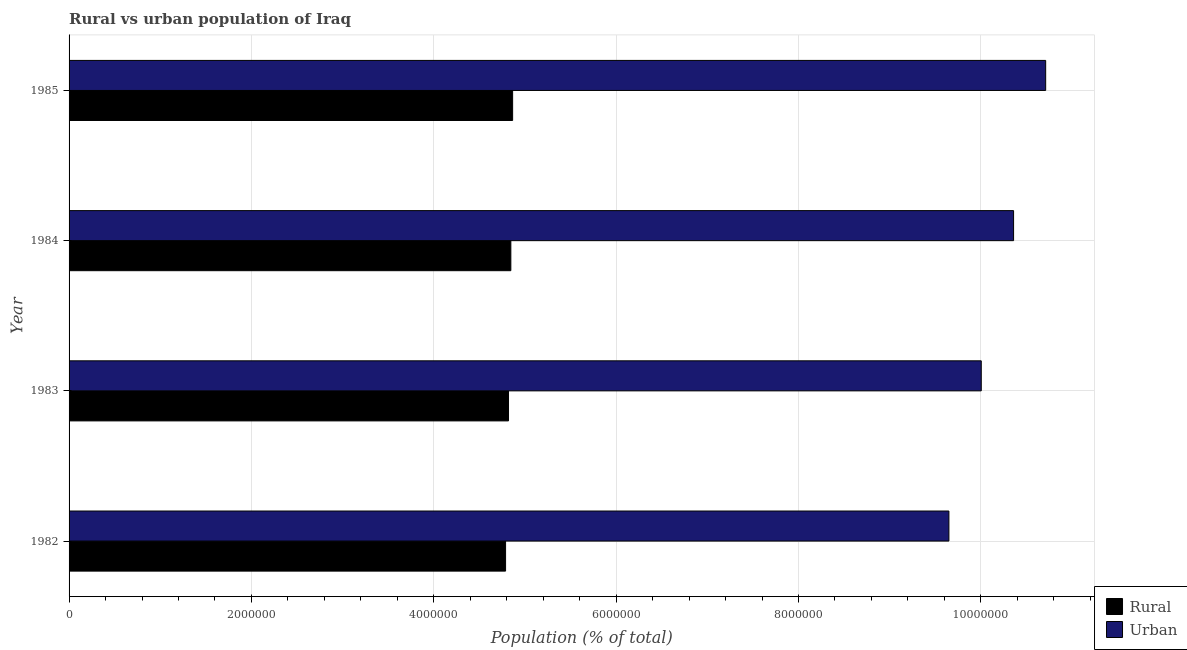How many different coloured bars are there?
Provide a succinct answer. 2. How many groups of bars are there?
Make the answer very short. 4. How many bars are there on the 1st tick from the top?
Make the answer very short. 2. What is the label of the 3rd group of bars from the top?
Provide a short and direct response. 1983. What is the rural population density in 1984?
Keep it short and to the point. 4.85e+06. Across all years, what is the maximum urban population density?
Provide a short and direct response. 1.07e+07. Across all years, what is the minimum urban population density?
Your answer should be very brief. 9.65e+06. In which year was the rural population density maximum?
Offer a very short reply. 1985. What is the total rural population density in the graph?
Your answer should be very brief. 1.93e+07. What is the difference between the rural population density in 1982 and that in 1984?
Make the answer very short. -5.78e+04. What is the difference between the urban population density in 1985 and the rural population density in 1984?
Provide a short and direct response. 5.87e+06. What is the average urban population density per year?
Provide a short and direct response. 1.02e+07. In the year 1982, what is the difference between the rural population density and urban population density?
Your answer should be compact. -4.86e+06. In how many years, is the rural population density greater than 10400000 %?
Provide a succinct answer. 0. Is the urban population density in 1983 less than that in 1985?
Offer a very short reply. Yes. Is the difference between the rural population density in 1983 and 1984 greater than the difference between the urban population density in 1983 and 1984?
Give a very brief answer. Yes. What is the difference between the highest and the second highest urban population density?
Your answer should be compact. 3.52e+05. What is the difference between the highest and the lowest rural population density?
Provide a succinct answer. 7.73e+04. In how many years, is the rural population density greater than the average rural population density taken over all years?
Your answer should be very brief. 2. Is the sum of the urban population density in 1983 and 1984 greater than the maximum rural population density across all years?
Keep it short and to the point. Yes. What does the 2nd bar from the top in 1984 represents?
Ensure brevity in your answer.  Rural. What does the 1st bar from the bottom in 1984 represents?
Provide a short and direct response. Rural. Does the graph contain grids?
Provide a short and direct response. Yes. Where does the legend appear in the graph?
Ensure brevity in your answer.  Bottom right. How are the legend labels stacked?
Make the answer very short. Vertical. What is the title of the graph?
Offer a very short reply. Rural vs urban population of Iraq. What is the label or title of the X-axis?
Provide a short and direct response. Population (% of total). What is the label or title of the Y-axis?
Provide a short and direct response. Year. What is the Population (% of total) of Rural in 1982?
Keep it short and to the point. 4.79e+06. What is the Population (% of total) in Urban in 1982?
Your answer should be very brief. 9.65e+06. What is the Population (% of total) of Rural in 1983?
Your answer should be compact. 4.82e+06. What is the Population (% of total) of Urban in 1983?
Offer a terse response. 1.00e+07. What is the Population (% of total) in Rural in 1984?
Your answer should be compact. 4.85e+06. What is the Population (% of total) in Urban in 1984?
Make the answer very short. 1.04e+07. What is the Population (% of total) of Rural in 1985?
Provide a short and direct response. 4.86e+06. What is the Population (% of total) of Urban in 1985?
Ensure brevity in your answer.  1.07e+07. Across all years, what is the maximum Population (% of total) of Rural?
Your answer should be compact. 4.86e+06. Across all years, what is the maximum Population (% of total) of Urban?
Offer a terse response. 1.07e+07. Across all years, what is the minimum Population (% of total) in Rural?
Give a very brief answer. 4.79e+06. Across all years, what is the minimum Population (% of total) in Urban?
Give a very brief answer. 9.65e+06. What is the total Population (% of total) in Rural in the graph?
Your response must be concise. 1.93e+07. What is the total Population (% of total) in Urban in the graph?
Your answer should be very brief. 4.07e+07. What is the difference between the Population (% of total) in Rural in 1982 and that in 1983?
Offer a very short reply. -3.22e+04. What is the difference between the Population (% of total) in Urban in 1982 and that in 1983?
Give a very brief answer. -3.55e+05. What is the difference between the Population (% of total) of Rural in 1982 and that in 1984?
Your answer should be very brief. -5.78e+04. What is the difference between the Population (% of total) in Urban in 1982 and that in 1984?
Your response must be concise. -7.09e+05. What is the difference between the Population (% of total) in Rural in 1982 and that in 1985?
Ensure brevity in your answer.  -7.73e+04. What is the difference between the Population (% of total) in Urban in 1982 and that in 1985?
Make the answer very short. -1.06e+06. What is the difference between the Population (% of total) in Rural in 1983 and that in 1984?
Provide a succinct answer. -2.56e+04. What is the difference between the Population (% of total) of Urban in 1983 and that in 1984?
Make the answer very short. -3.54e+05. What is the difference between the Population (% of total) of Rural in 1983 and that in 1985?
Provide a short and direct response. -4.51e+04. What is the difference between the Population (% of total) of Urban in 1983 and that in 1985?
Provide a short and direct response. -7.06e+05. What is the difference between the Population (% of total) of Rural in 1984 and that in 1985?
Provide a succinct answer. -1.95e+04. What is the difference between the Population (% of total) in Urban in 1984 and that in 1985?
Provide a short and direct response. -3.52e+05. What is the difference between the Population (% of total) of Rural in 1982 and the Population (% of total) of Urban in 1983?
Keep it short and to the point. -5.22e+06. What is the difference between the Population (% of total) of Rural in 1982 and the Population (% of total) of Urban in 1984?
Give a very brief answer. -5.57e+06. What is the difference between the Population (% of total) in Rural in 1982 and the Population (% of total) in Urban in 1985?
Your response must be concise. -5.92e+06. What is the difference between the Population (% of total) in Rural in 1983 and the Population (% of total) in Urban in 1984?
Your response must be concise. -5.54e+06. What is the difference between the Population (% of total) in Rural in 1983 and the Population (% of total) in Urban in 1985?
Your answer should be compact. -5.89e+06. What is the difference between the Population (% of total) of Rural in 1984 and the Population (% of total) of Urban in 1985?
Your answer should be very brief. -5.87e+06. What is the average Population (% of total) of Rural per year?
Provide a short and direct response. 4.83e+06. What is the average Population (% of total) of Urban per year?
Give a very brief answer. 1.02e+07. In the year 1982, what is the difference between the Population (% of total) in Rural and Population (% of total) in Urban?
Offer a terse response. -4.86e+06. In the year 1983, what is the difference between the Population (% of total) in Rural and Population (% of total) in Urban?
Give a very brief answer. -5.19e+06. In the year 1984, what is the difference between the Population (% of total) of Rural and Population (% of total) of Urban?
Provide a short and direct response. -5.51e+06. In the year 1985, what is the difference between the Population (% of total) of Rural and Population (% of total) of Urban?
Ensure brevity in your answer.  -5.85e+06. What is the ratio of the Population (% of total) of Urban in 1982 to that in 1983?
Provide a short and direct response. 0.96. What is the ratio of the Population (% of total) of Rural in 1982 to that in 1984?
Offer a very short reply. 0.99. What is the ratio of the Population (% of total) of Urban in 1982 to that in 1984?
Provide a succinct answer. 0.93. What is the ratio of the Population (% of total) of Rural in 1982 to that in 1985?
Give a very brief answer. 0.98. What is the ratio of the Population (% of total) in Urban in 1982 to that in 1985?
Offer a terse response. 0.9. What is the ratio of the Population (% of total) of Rural in 1983 to that in 1984?
Your response must be concise. 0.99. What is the ratio of the Population (% of total) of Urban in 1983 to that in 1984?
Make the answer very short. 0.97. What is the ratio of the Population (% of total) in Rural in 1983 to that in 1985?
Offer a very short reply. 0.99. What is the ratio of the Population (% of total) of Urban in 1983 to that in 1985?
Offer a terse response. 0.93. What is the ratio of the Population (% of total) of Rural in 1984 to that in 1985?
Your response must be concise. 1. What is the ratio of the Population (% of total) of Urban in 1984 to that in 1985?
Ensure brevity in your answer.  0.97. What is the difference between the highest and the second highest Population (% of total) in Rural?
Provide a succinct answer. 1.95e+04. What is the difference between the highest and the second highest Population (% of total) of Urban?
Keep it short and to the point. 3.52e+05. What is the difference between the highest and the lowest Population (% of total) of Rural?
Your answer should be compact. 7.73e+04. What is the difference between the highest and the lowest Population (% of total) of Urban?
Provide a succinct answer. 1.06e+06. 